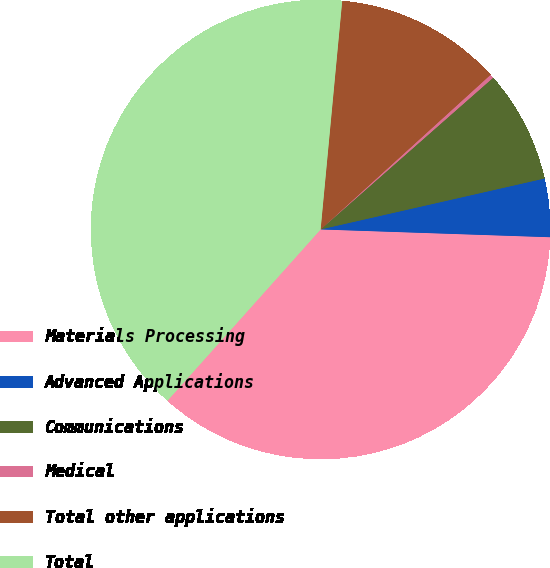Convert chart. <chart><loc_0><loc_0><loc_500><loc_500><pie_chart><fcel>Materials Processing<fcel>Advanced Applications<fcel>Communications<fcel>Medical<fcel>Total other applications<fcel>Total<nl><fcel>36.07%<fcel>4.1%<fcel>7.92%<fcel>0.27%<fcel>11.75%<fcel>39.89%<nl></chart> 